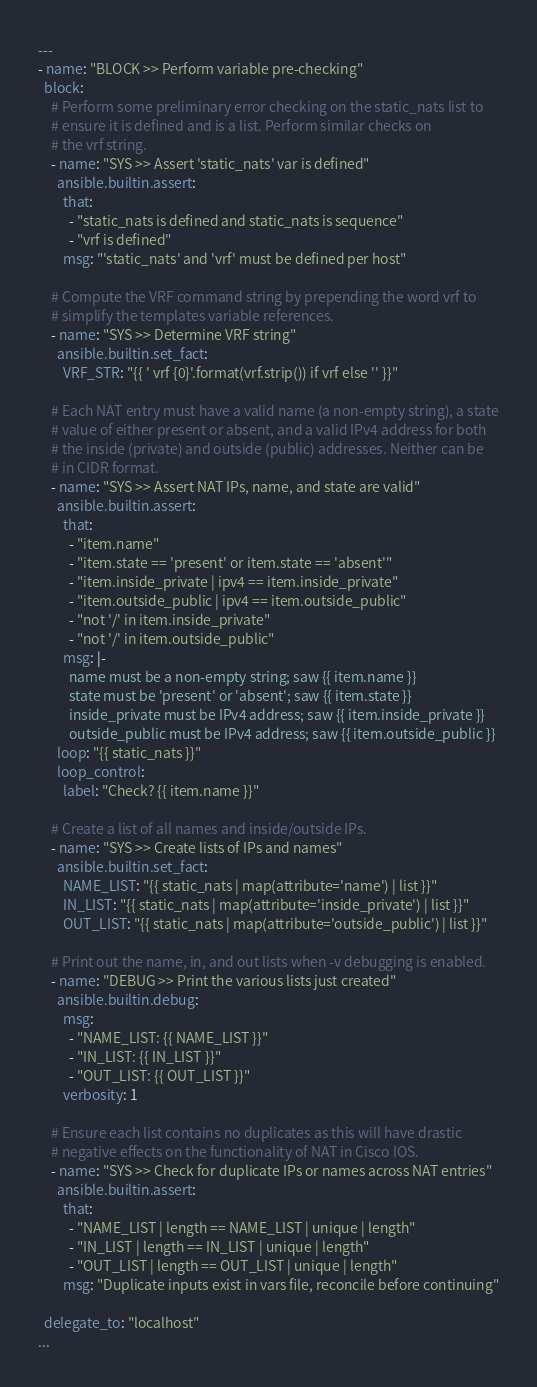Convert code to text. <code><loc_0><loc_0><loc_500><loc_500><_YAML_>---
- name: "BLOCK >> Perform variable pre-checking"
  block:
    # Perform some preliminary error checking on the static_nats list to
    # ensure it is defined and is a list. Perform similar checks on
    # the vrf string.
    - name: "SYS >> Assert 'static_nats' var is defined"
      ansible.builtin.assert:
        that:
          - "static_nats is defined and static_nats is sequence"
          - "vrf is defined"
        msg: "'static_nats' and 'vrf' must be defined per host"

    # Compute the VRF command string by prepending the word vrf to
    # simplify the templates variable references.
    - name: "SYS >> Determine VRF string"
      ansible.builtin.set_fact:
        VRF_STR: "{{ ' vrf {0}'.format(vrf.strip()) if vrf else '' }}"

    # Each NAT entry must have a valid name (a non-empty string), a state
    # value of either present or absent, and a valid IPv4 address for both
    # the inside (private) and outside (public) addresses. Neither can be
    # in CIDR format.
    - name: "SYS >> Assert NAT IPs, name, and state are valid"
      ansible.builtin.assert:
        that:
          - "item.name"
          - "item.state == 'present' or item.state == 'absent'"
          - "item.inside_private | ipv4 == item.inside_private"
          - "item.outside_public | ipv4 == item.outside_public"
          - "not '/' in item.inside_private"
          - "not '/' in item.outside_public"
        msg: |-
          name must be a non-empty string; saw {{ item.name }}
          state must be 'present' or 'absent'; saw {{ item.state }}
          inside_private must be IPv4 address; saw {{ item.inside_private }}
          outside_public must be IPv4 address; saw {{ item.outside_public }}
      loop: "{{ static_nats }}"
      loop_control:
        label: "Check? {{ item.name }}"

    # Create a list of all names and inside/outside IPs.
    - name: "SYS >> Create lists of IPs and names"
      ansible.builtin.set_fact:
        NAME_LIST: "{{ static_nats | map(attribute='name') | list }}"
        IN_LIST: "{{ static_nats | map(attribute='inside_private') | list }}"
        OUT_LIST: "{{ static_nats | map(attribute='outside_public') | list }}"

    # Print out the name, in, and out lists when -v debugging is enabled.
    - name: "DEBUG >> Print the various lists just created"
      ansible.builtin.debug:
        msg:
          - "NAME_LIST: {{ NAME_LIST }}"
          - "IN_LIST: {{ IN_LIST }}"
          - "OUT_LIST: {{ OUT_LIST }}"
        verbosity: 1

    # Ensure each list contains no duplicates as this will have drastic
    # negative effects on the functionality of NAT in Cisco IOS.
    - name: "SYS >> Check for duplicate IPs or names across NAT entries"
      ansible.builtin.assert:
        that:
          - "NAME_LIST | length == NAME_LIST | unique | length"
          - "IN_LIST | length == IN_LIST | unique | length"
          - "OUT_LIST | length == OUT_LIST | unique | length"
        msg: "Duplicate inputs exist in vars file, reconcile before continuing"

  delegate_to: "localhost"
...
</code> 